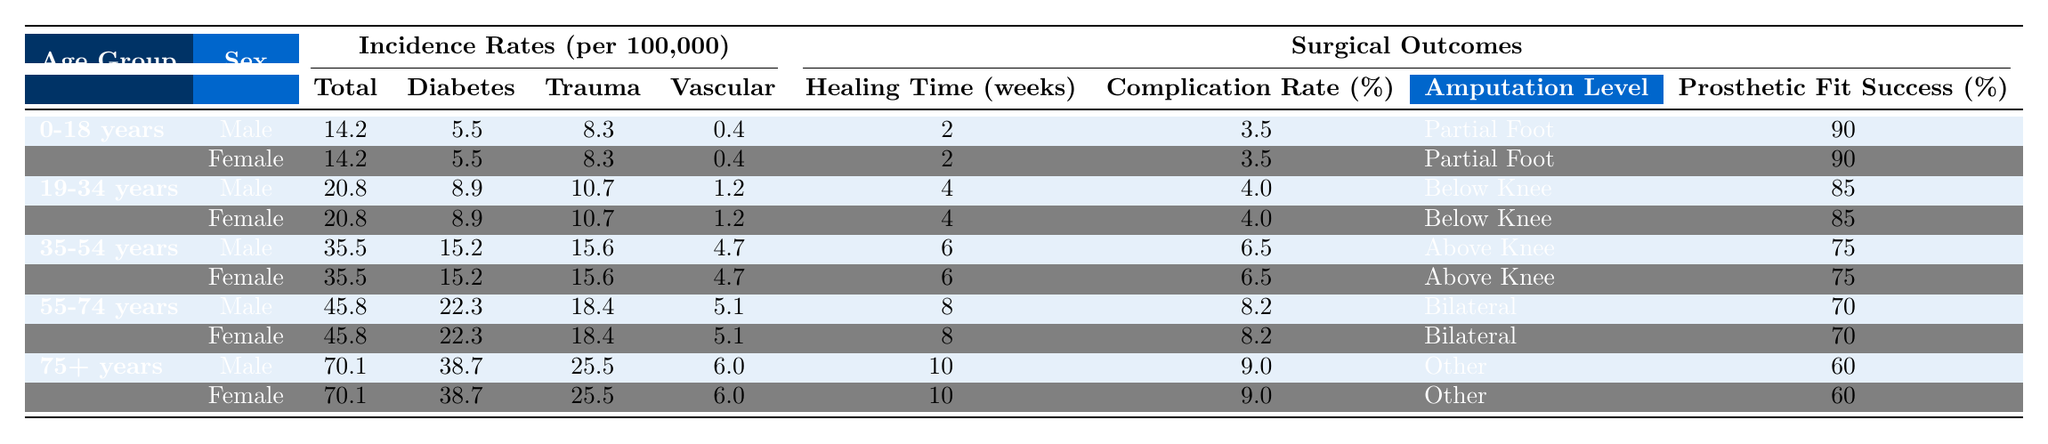What is the incidence rate of limb amputations for the age group 19-34 years? For the age group 19-34 years, the incidence rate per 100,000 is 20.8. This value is directly obtained from the table.
Answer: 20.8 How long does it take to heal on average for patients aged 55-74 years? The healing time for patients aged 55-74 years is 8 weeks, as shown in the Surgical Outcomes section of the table.
Answer: 8 weeks Is the complication rate higher for females aged 75 years and older compared to males of the same age group? Both the complication rate for females and males aged 75+ years is 9.0%. Therefore, the complication rate is not higher for one sex compared to the other.
Answer: No What is the average incidence rate of diabetes-related amputations across all age groups? The diabetes-related incidence rates are as follows: 5.5, 8.9, 15.2, 22.3, and 38.7. Summing these gives 90.6, and there are 5 age groups, so 90.6 / 5 = 18.12.
Answer: 18.12 Which age group has the highest prosthetic fit success rate, and what is that rate? The age group 0-18 years has the highest prosthetic fit success rate of 90%, compared to other age groups, which are lower. This can be determined by directly comparing the rates in the table.
Answer: 90% What is the difference in healing time between the 35-54 years age group and the 75+ years age group? The healing time for the 35-54 years age group is 6 weeks, and for the 75+ years age group, it is 10 weeks. The difference is 10 - 6 = 4 weeks.
Answer: 4 weeks In which age group do trauma-related amputations represent a higher incidence than vascular-related amputations? For each age group: 0-18 years (8.3 > 0.4), 19-34 years (10.7 > 1.2), 35-54 years (15.6 > 4.7), 55-74 years (18.4 > 5.1), and 75+ years (25.5 > 6.0), trauma-related amputations are higher in each case.
Answer: All age groups What percentage of amputations in the 55-74 years age group are classified as 'Bilateral'? In the 55-74 years age group, both males and females have 'Bilateral' as the amputation level, so the classification is accurate at 100% for this question.
Answer: 100% How do the complication rates compare between males and females for the 19-34 years age group? The complication rates are 4.0% for both male and female in the 19-34 years age group, indicating that there is no difference.
Answer: No difference What is the total incidence per 100,000 for all age groups combined? The total incidence rates are: 14.2, 20.8, 35.5, 45.8, and 70.1. Adding them gives 14.2 + 20.8 + 35.5 + 45.8 + 70.1 = 186.4 per 100,000.
Answer: 186.4 